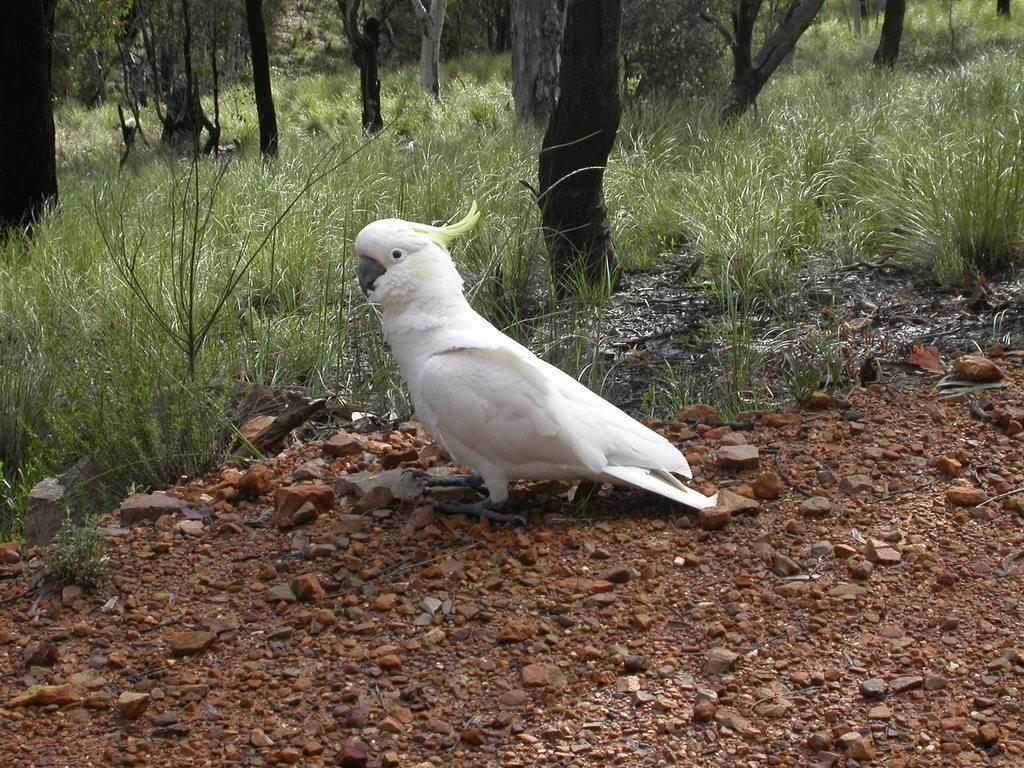Describe this image in one or two sentences. In this image I can see a bird in white color, background I can see trees and grass in green color. 